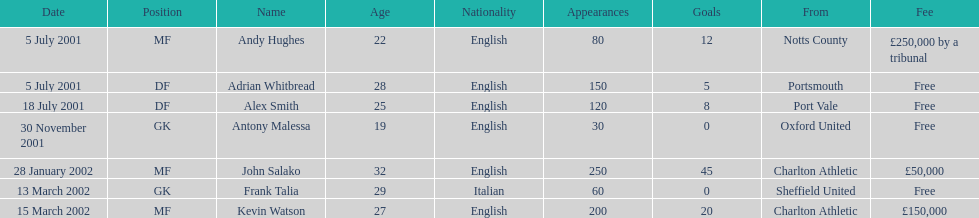Which transfer in was next after john salako's in 2002? Frank Talia. 